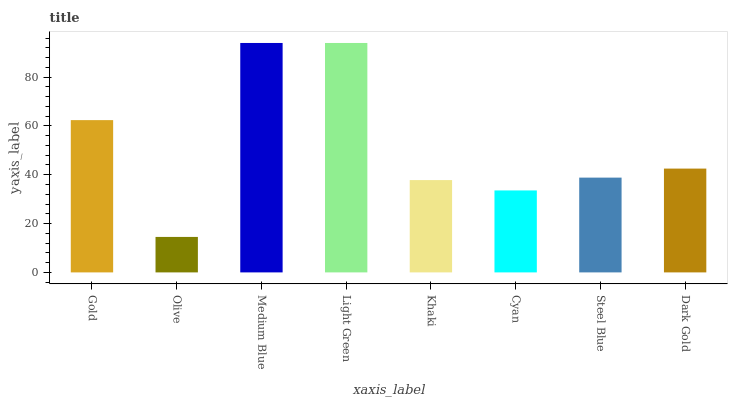Is Olive the minimum?
Answer yes or no. Yes. Is Medium Blue the maximum?
Answer yes or no. Yes. Is Medium Blue the minimum?
Answer yes or no. No. Is Olive the maximum?
Answer yes or no. No. Is Medium Blue greater than Olive?
Answer yes or no. Yes. Is Olive less than Medium Blue?
Answer yes or no. Yes. Is Olive greater than Medium Blue?
Answer yes or no. No. Is Medium Blue less than Olive?
Answer yes or no. No. Is Dark Gold the high median?
Answer yes or no. Yes. Is Steel Blue the low median?
Answer yes or no. Yes. Is Khaki the high median?
Answer yes or no. No. Is Cyan the low median?
Answer yes or no. No. 